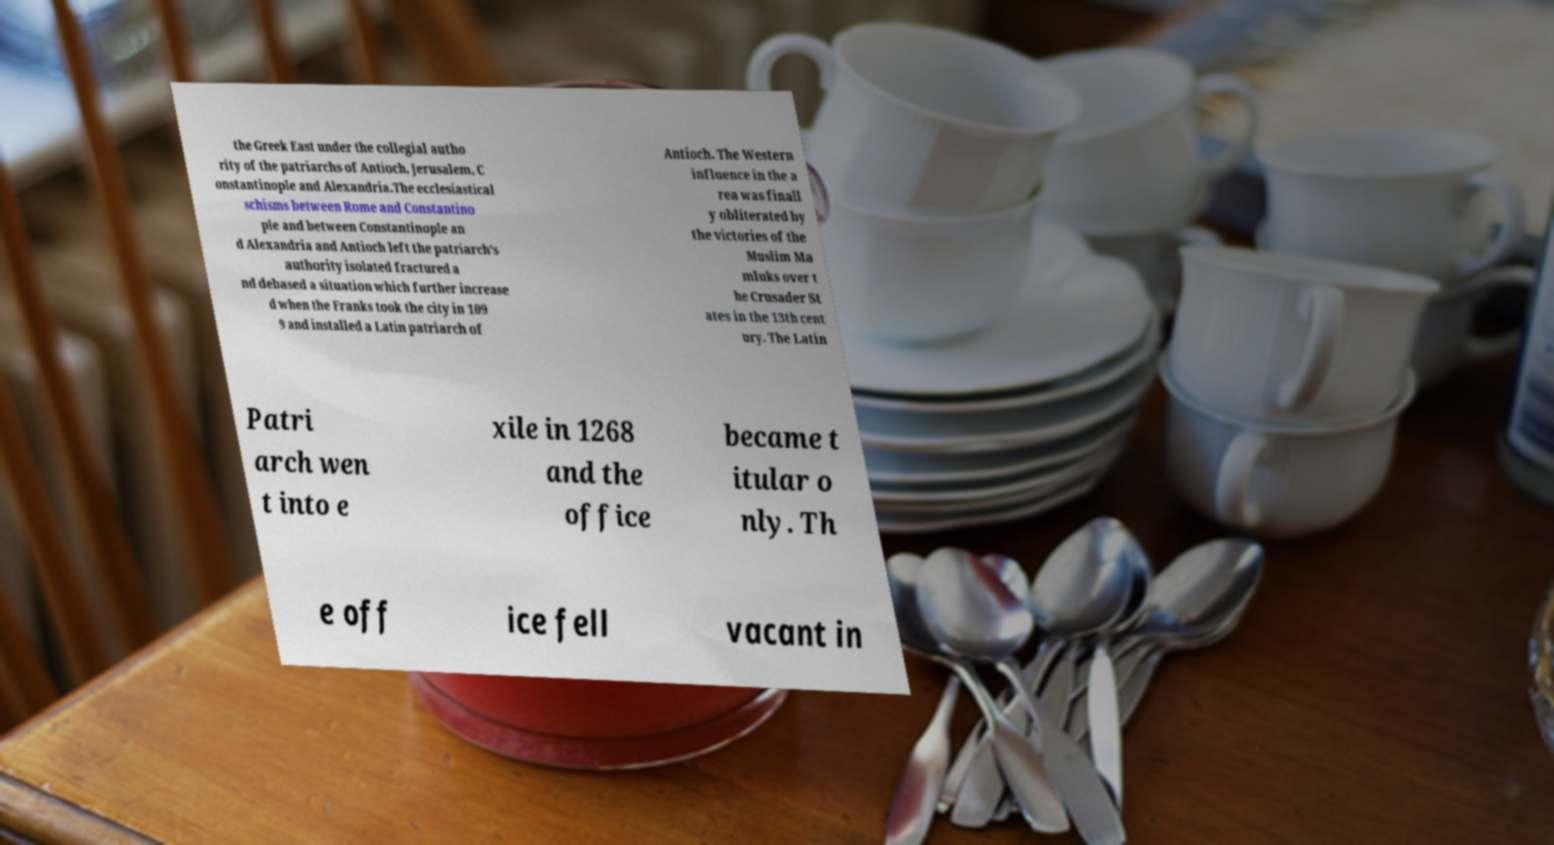I need the written content from this picture converted into text. Can you do that? the Greek East under the collegial autho rity of the patriarchs of Antioch, Jerusalem, C onstantinople and Alexandria.The ecclesiastical schisms between Rome and Constantino ple and between Constantinople an d Alexandria and Antioch left the patriarch's authority isolated fractured a nd debased a situation which further increase d when the Franks took the city in 109 9 and installed a Latin patriarch of Antioch. The Western influence in the a rea was finall y obliterated by the victories of the Muslim Ma mluks over t he Crusader St ates in the 13th cent ury. The Latin Patri arch wen t into e xile in 1268 and the office became t itular o nly. Th e off ice fell vacant in 